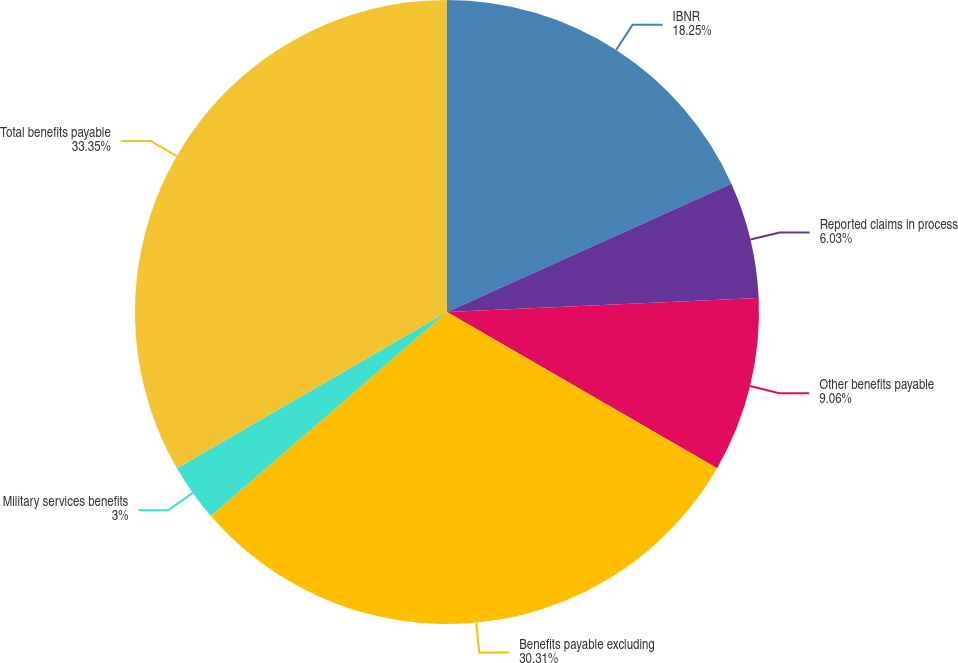Convert chart. <chart><loc_0><loc_0><loc_500><loc_500><pie_chart><fcel>IBNR<fcel>Reported claims in process<fcel>Other benefits payable<fcel>Benefits payable excluding<fcel>Military services benefits<fcel>Total benefits payable<nl><fcel>18.25%<fcel>6.03%<fcel>9.06%<fcel>30.31%<fcel>3.0%<fcel>33.34%<nl></chart> 